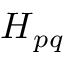<formula> <loc_0><loc_0><loc_500><loc_500>H _ { p q }</formula> 